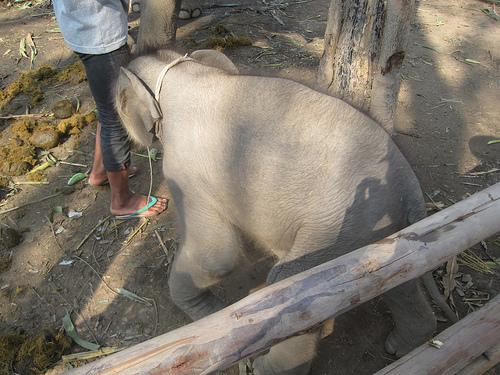What is the primary interaction between the elephant and the human in this image? The baby elephant with its head down is approaching the human in the pen, suggesting a friendly interaction between them. What are some objects found on the ground in the image? Elephant poop, leaves, twigs, and patches of dirt are scattered on the ground in the image. What is a unique feature of the baby elephant's appearance that stands out in the image? The baby elephant has floppy folded ears that make it look adorable and unique. What type of footwear is the person in the enclosure wearing? The person in the enclosure is wearing teal flip flops. Identify the primary object in the image and give a brief description. A small grey baby elephant is in the enclosure with a light-colored string around its neck, floppy folded ears, and black hair on its head. What type of tree is visible in the image and describe its appearance. A tan tree trunk with medium trunk size and elephant toes behind it is visible in the image. Describe the person's outfit who is present in the elephant enclosure. The person in the elephant enclosure is wearing a light blue t-shirt, grey jeans, and teal flip flops. Mention the type of fence present in the image and describe its features. A wooden two-spoke fence made up of large sanded logs serves as the safety railing of the enclosure in the image. Give a brief description of the image for a visual entailment task. A baby elephant and a person are present in an enclosure with a wooden fence, tree trunk, and scattered debris on the ground. The person is wearing a light blue t-shirt, grey jeans, and teal flip flops, while the baby elephant has floppy ears and a rope around its neck. Explain the type of task a product advertisement could focus on in this image. A product advertisement could promote eco-friendly elephant habitats or showcase a brand of clothing for zookeepers worn by the person in the enclosure. 